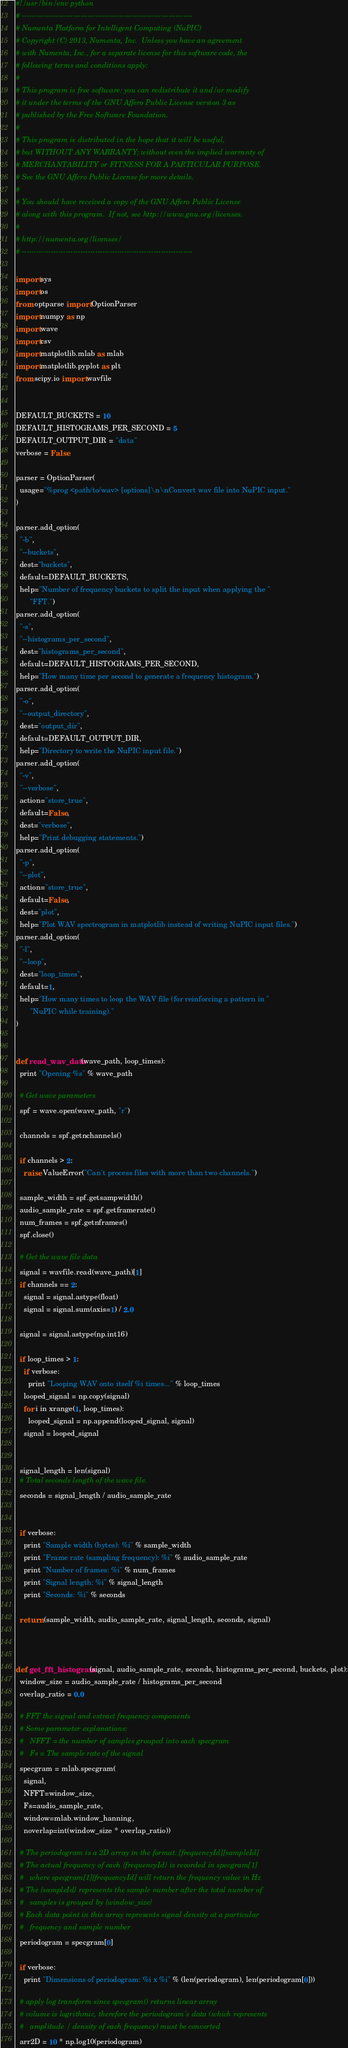<code> <loc_0><loc_0><loc_500><loc_500><_Python_>#!/usr/bin/env python
# ----------------------------------------------------------------------
# Numenta Platform for Intelligent Computing (NuPIC)
# Copyright (C) 2013, Numenta, Inc.  Unless you have an agreement
# with Numenta, Inc., for a separate license for this software code, the
# following terms and conditions apply:
#
# This program is free software: you can redistribute it and/or modify
# it under the terms of the GNU Affero Public License version 3 as
# published by the Free Software Foundation.
#
# This program is distributed in the hope that it will be useful,
# but WITHOUT ANY WARRANTY; without even the implied warranty of
# MERCHANTABILITY or FITNESS FOR A PARTICULAR PURPOSE.
# See the GNU Affero Public License for more details.
#
# You should have received a copy of the GNU Affero Public License
# along with this program.  If not, see http://www.gnu.org/licenses.
#
# http://numenta.org/licenses/
# ----------------------------------------------------------------------

import sys
import os
from optparse import OptionParser
import numpy as np
import wave
import csv
import matplotlib.mlab as mlab
import matplotlib.pyplot as plt
from scipy.io import wavfile


DEFAULT_BUCKETS = 10
DEFAULT_HISTOGRAMS_PER_SECOND = 5
DEFAULT_OUTPUT_DIR = "data"
verbose = False

parser = OptionParser(
  usage="%prog <path/to/wav> [options]\n\nConvert wav file into NuPIC input."
)

parser.add_option(
  "-b",
  "--buckets",
  dest="buckets",
  default=DEFAULT_BUCKETS,
  help="Number of frequency buckets to split the input when applying the "
       "FFT.")
parser.add_option(
  "-s",
  "--histograms_per_second",
  dest="histograms_per_second",
  default=DEFAULT_HISTOGRAMS_PER_SECOND,
  help="How many time per second to generate a frequency histogram.")
parser.add_option(
  "-o",
  "--output_directory",
  dest="output_dir",
  default=DEFAULT_OUTPUT_DIR,
  help="Directory to write the NuPIC input file.")
parser.add_option(
  "-v",
  "--verbose",
  action="store_true",
  default=False,
  dest="verbose",
  help="Print debugging statements.")
parser.add_option(
  "-p",
  "--plot",
  action="store_true",
  default=False,
  dest="plot",
  help="Plot WAV spectrogram in matplotlib instead of writing NuPIC input files.")
parser.add_option(
  "-l",
  "--loop",
  dest="loop_times",
  default=1,
  help="How many times to loop the WAV file (for reinforcing a pattern in "
       "NuPIC while training)."
)


def read_wav_data(wave_path, loop_times):
  print "Opening %s" % wave_path
  
  # Get wave parameters
  spf = wave.open(wave_path, "r")
  
  channels = spf.getnchannels()
  
  if channels > 2:
    raise ValueError("Can't process files with more than two channels.")
  
  sample_width = spf.getsampwidth()
  audio_sample_rate = spf.getframerate()
  num_frames = spf.getnframes()
  spf.close()
  
  # Get the wave file data
  signal = wavfile.read(wave_path)[1]
  if channels == 2:
    signal = signal.astype(float)
    signal = signal.sum(axis=1) / 2.0
      
  signal = signal.astype(np.int16)

  if loop_times > 1:
    if verbose:
      print "Looping WAV onto itself %i times..." % loop_times
    looped_signal = np.copy(signal)
    for i in xrange(1, loop_times):
      looped_signal = np.append(looped_signal, signal)
    signal = looped_signal


  signal_length = len(signal)
  # Total seconds length of the wave file.
  seconds = signal_length / audio_sample_rate


  if verbose:
    print "Sample width (bytes): %i" % sample_width
    print "Frame rate (sampling frequency): %i" % audio_sample_rate
    print "Number of frames: %i" % num_frames
    print "Signal length: %i" % signal_length
    print "Seconds: %i" % seconds

  return (sample_width, audio_sample_rate, signal_length, seconds, signal)



def get_fft_histogram(signal, audio_sample_rate, seconds, histograms_per_second, buckets, plot):
  window_size = audio_sample_rate / histograms_per_second
  overlap_ratio = 0.0

  # FFT the signal and extract frequency components
  # Some parameter explanations:
  #   NFFT = the number of samples grouped into each specgram
  #   Fs = The sample rate of the signal
  specgram = mlab.specgram(
    signal,
    NFFT=window_size,
    Fs=audio_sample_rate,
    window=mlab.window_hanning,
    noverlap=int(window_size * overlap_ratio))

  # The periodogram is a 2D array in the format: [frequencyId][sampleId]
  # The actual frequency of each {frequencyId} is recorded in specgram[1]
  #   where specgram[1][frequencyId] will return the frequency value in Hz
  # The {sampleId} represents the sample number after the total number of
  #   samples is grouped by {window_size}
  # Each data point in this array represents signal density at a particular
  #   frequency and sample number
  periodogram = specgram[0]

  if verbose:
    print "Dimensions of periodogram: %i x %i" % (len(periodogram), len(periodogram[0]))

  # apply log transform since specgram() returns linear array
  # volume is logrithmic, therefore the periodogram's data (which represents 
  #   amplitude / density of each frequency) must be converted
  arr2D = 10 * np.log10(periodogram)</code> 